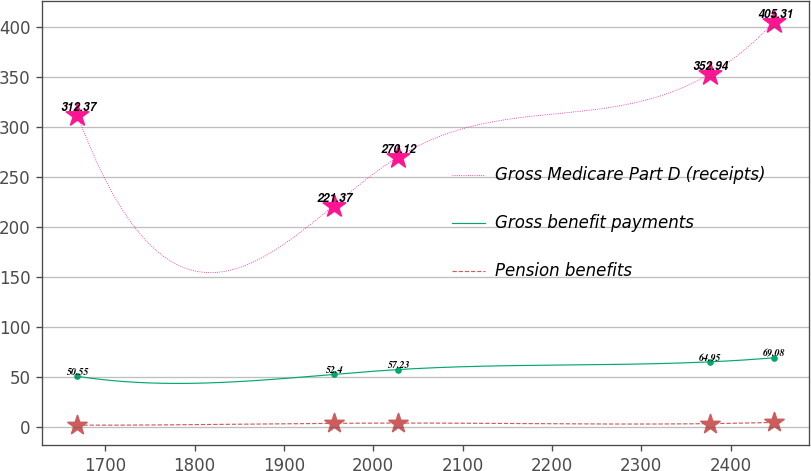Convert chart to OTSL. <chart><loc_0><loc_0><loc_500><loc_500><line_chart><ecel><fcel>Gross Medicare Part D (receipts)<fcel>Gross benefit payments<fcel>Pension benefits<nl><fcel>1668.67<fcel>312.37<fcel>50.55<fcel>1.63<nl><fcel>1955.98<fcel>221.37<fcel>52.4<fcel>3.44<nl><fcel>2028.08<fcel>270.12<fcel>57.23<fcel>3.72<nl><fcel>2376.89<fcel>352.94<fcel>64.95<fcel>3.16<nl><fcel>2448.99<fcel>405.31<fcel>69.08<fcel>4.39<nl></chart> 